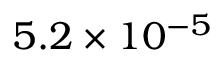Convert formula to latex. <formula><loc_0><loc_0><loc_500><loc_500>5 . 2 \times 1 0 ^ { - 5 }</formula> 